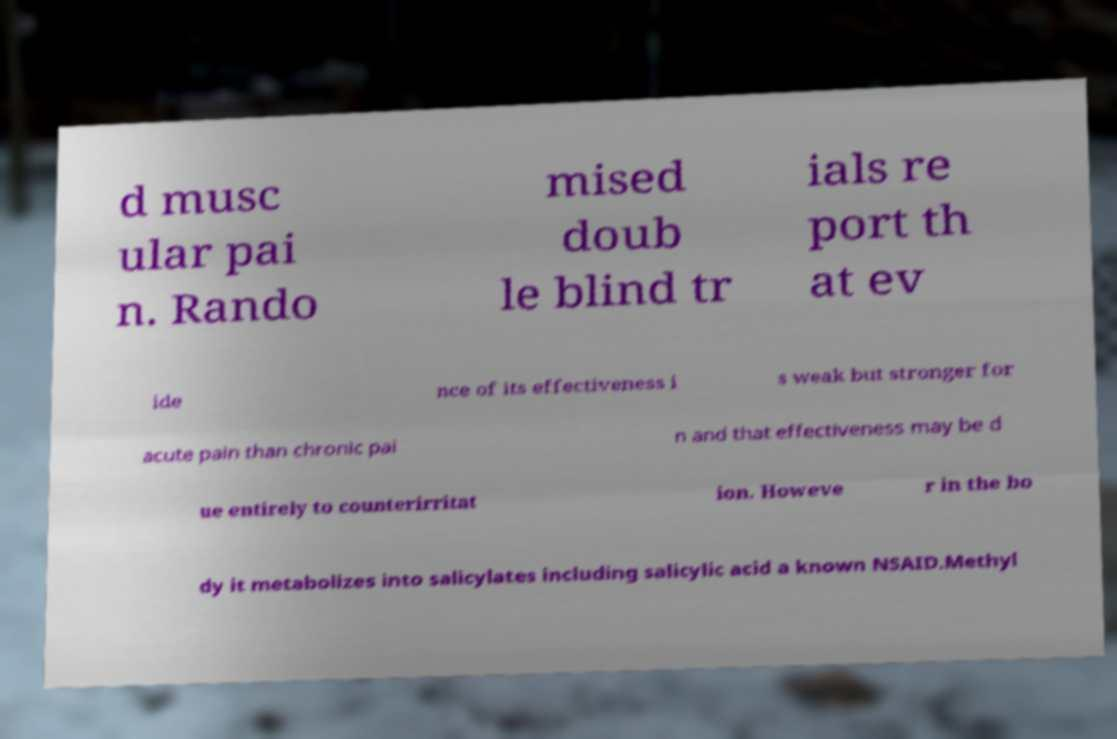Can you read and provide the text displayed in the image?This photo seems to have some interesting text. Can you extract and type it out for me? d musc ular pai n. Rando mised doub le blind tr ials re port th at ev ide nce of its effectiveness i s weak but stronger for acute pain than chronic pai n and that effectiveness may be d ue entirely to counterirritat ion. Howeve r in the bo dy it metabolizes into salicylates including salicylic acid a known NSAID.Methyl 